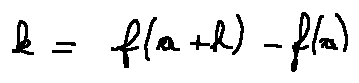<formula> <loc_0><loc_0><loc_500><loc_500>k = f ( a + h ) - f ( a )</formula> 